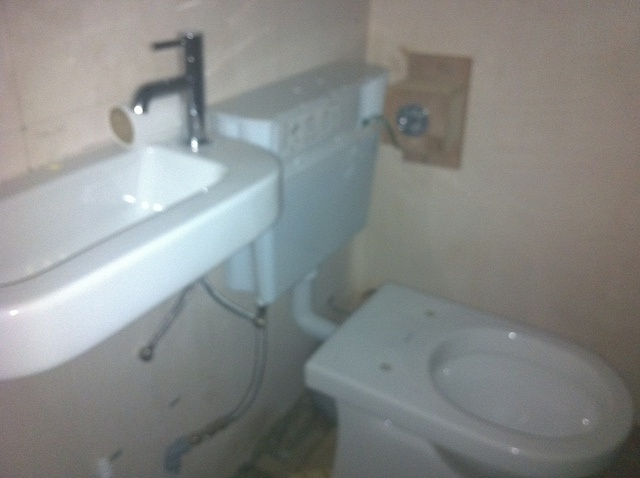Describe the objects in this image and their specific colors. I can see toilet in gray tones and sink in gray, lightgray, darkgray, and lightblue tones in this image. 